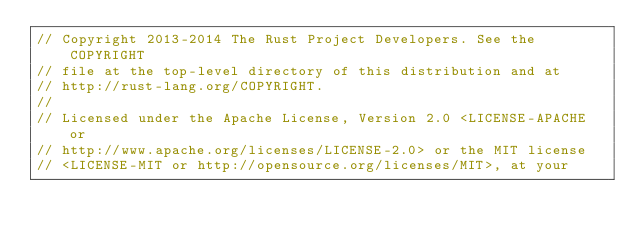Convert code to text. <code><loc_0><loc_0><loc_500><loc_500><_Rust_>// Copyright 2013-2014 The Rust Project Developers. See the COPYRIGHT
// file at the top-level directory of this distribution and at
// http://rust-lang.org/COPYRIGHT.
//
// Licensed under the Apache License, Version 2.0 <LICENSE-APACHE or
// http://www.apache.org/licenses/LICENSE-2.0> or the MIT license
// <LICENSE-MIT or http://opensource.org/licenses/MIT>, at your</code> 